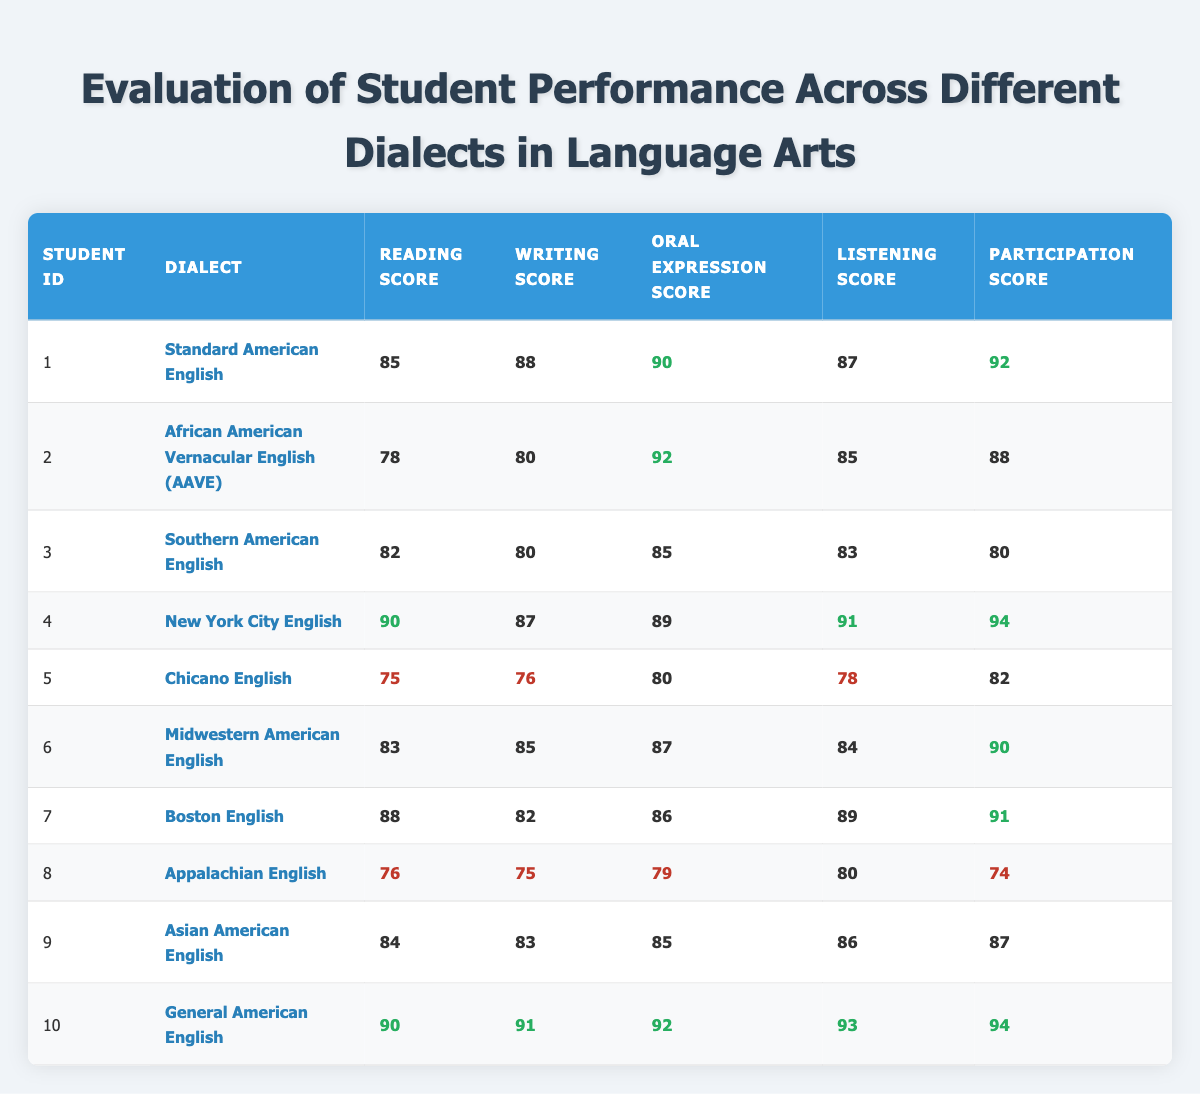What is the highest reading score achieved by a student? To find the highest reading score, I will look through the reading scores provided in the table. The highest score listed is 90, achieved by students with IDs 4 and 10.
Answer: 90 Which dialect had the lowest participation score? I will check the participation scores and compare them across all dialects. The lowest participation score is 74, from the Appalachian English dialect (student ID 8).
Answer: Appalachian English What is the average writing score of students using Southern American English and African American Vernacular English? I will first find the writing scores for both dialects: Southern American English has a score of 80 (student ID 3) and African American Vernacular English has a score of 80 (student ID 2). The average can be calculated as (80 + 80) / 2 = 80.
Answer: 80 Did any student score below 80 in listening? I will check the listening scores and find which ones scored lower than 80. The Appalachian English dialect (student ID 8) scored 80, and Chicano English (student ID 5) scored 78, which is below 80. Therefore, the statement is true.
Answer: Yes What is the difference between the highest and lowest reading scores? The highest reading score is 90 (achieved by students 4 and 10) and the lowest is 75 (Chicano English, student ID 5). The difference is 90 - 75 = 15.
Answer: 15 